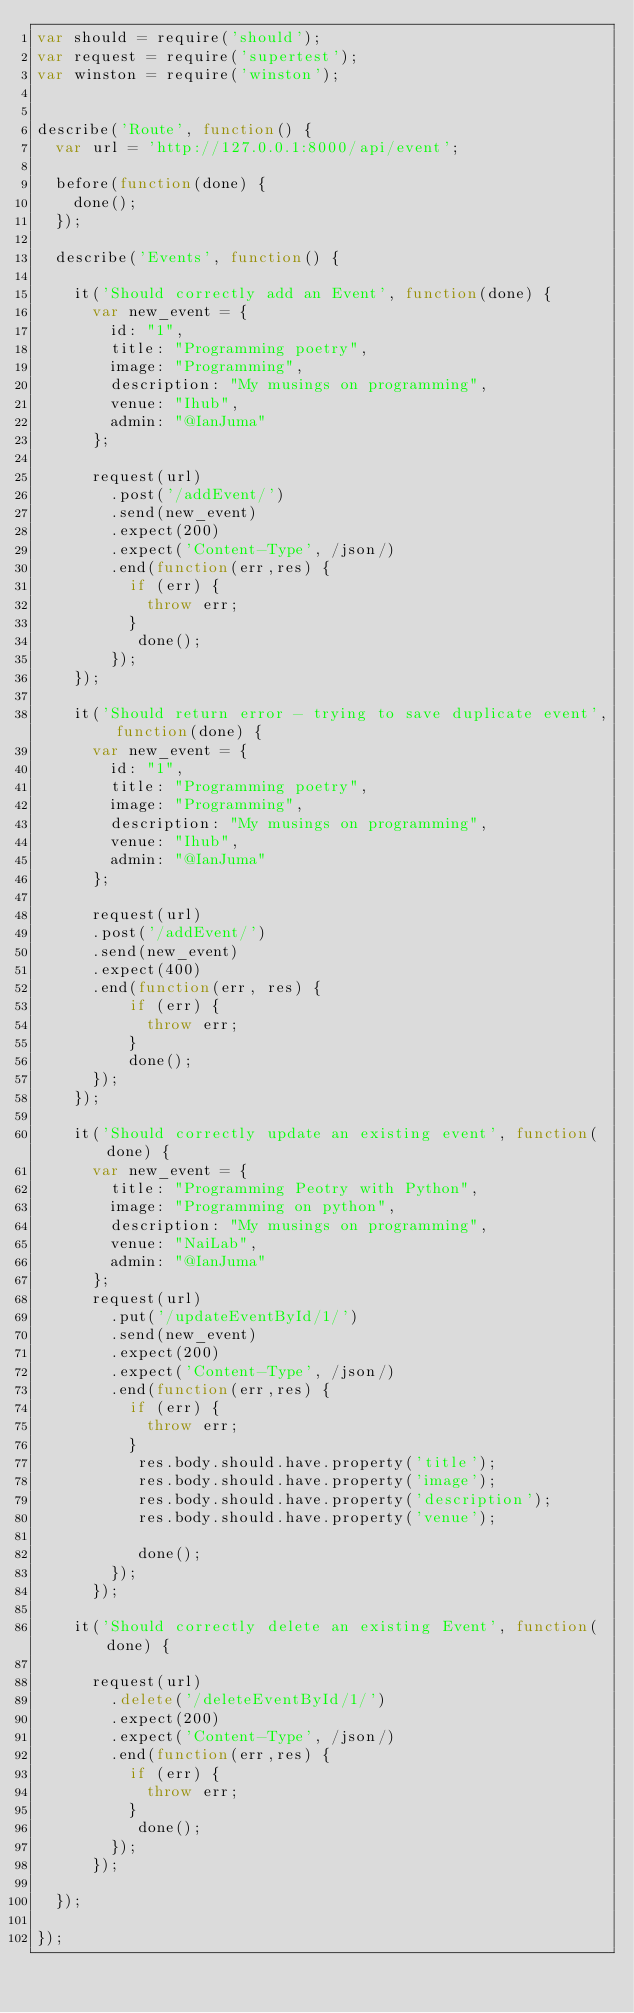Convert code to text. <code><loc_0><loc_0><loc_500><loc_500><_JavaScript_>var should = require('should');
var request = require('supertest');
var winston = require('winston');


describe('Route', function() {
  var url = 'http://127.0.0.1:8000/api/event';

  before(function(done) {
    done();
  });

  describe('Events', function() {

    it('Should correctly add an Event', function(done) {
      var new_event = {
        id: "1",
        title: "Programming poetry",
        image: "Programming",
        description: "My musings on programming",
        venue: "Ihub",
        admin: "@IanJuma"
      };

      request(url)
        .post('/addEvent/')
        .send(new_event)
        .expect(200)
        .expect('Content-Type', /json/)
        .end(function(err,res) {
          if (err) {
            throw err;
          }
           done();
        });
    });

    it('Should return error - trying to save duplicate event', function(done) {
      var new_event = {
        id: "1",
        title: "Programming poetry",
        image: "Programming",
        description: "My musings on programming",
        venue: "Ihub",
        admin: "@IanJuma"
      };

      request(url)
      .post('/addEvent/')
      .send(new_event)
      .expect(400)
      .end(function(err, res) {
          if (err) {
            throw err;
          }
          done();
      });
    });

    it('Should correctly update an existing event', function(done) {
      var new_event = {
        title: "Programming Peotry with Python",
        image: "Programming on python",
        description: "My musings on programming",
        venue: "NaiLab",
        admin: "@IanJuma"
      };
      request(url)
      	.put('/updateEventById/1/')
      	.send(new_event)
        .expect(200)
      	.expect('Content-Type', /json/)
      	.end(function(err,res) {
      		if (err) {
      			throw err;
      		}
      		 res.body.should.have.property('title');
           res.body.should.have.property('image');
           res.body.should.have.property('description');
           res.body.should.have.property('venue');

      		 done();
      	});
      });

    it('Should correctly delete an existing Event', function(done) {

      request(url)
        .delete('/deleteEventById/1/')
        .expect(200)
        .expect('Content-Type', /json/)
        .end(function(err,res) {
          if (err) {
            throw err;
          }
           done();
        });
      });

  });

});
</code> 